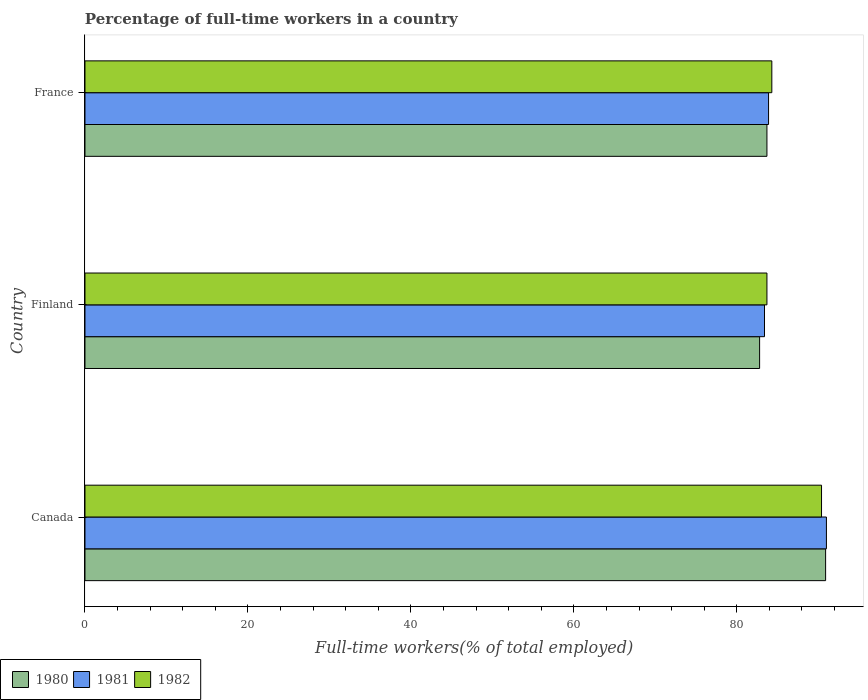How many different coloured bars are there?
Offer a terse response. 3. Are the number of bars per tick equal to the number of legend labels?
Offer a very short reply. Yes. Are the number of bars on each tick of the Y-axis equal?
Give a very brief answer. Yes. How many bars are there on the 2nd tick from the top?
Your answer should be compact. 3. How many bars are there on the 3rd tick from the bottom?
Your response must be concise. 3. What is the label of the 3rd group of bars from the top?
Give a very brief answer. Canada. What is the percentage of full-time workers in 1981 in France?
Your answer should be compact. 83.9. Across all countries, what is the maximum percentage of full-time workers in 1982?
Offer a very short reply. 90.4. Across all countries, what is the minimum percentage of full-time workers in 1980?
Keep it short and to the point. 82.8. In which country was the percentage of full-time workers in 1980 minimum?
Ensure brevity in your answer.  Finland. What is the total percentage of full-time workers in 1980 in the graph?
Provide a succinct answer. 257.4. What is the difference between the percentage of full-time workers in 1980 in Finland and that in France?
Offer a terse response. -0.9. What is the difference between the percentage of full-time workers in 1981 in France and the percentage of full-time workers in 1980 in Finland?
Provide a succinct answer. 1.1. What is the average percentage of full-time workers in 1982 per country?
Give a very brief answer. 86.13. What is the difference between the percentage of full-time workers in 1981 and percentage of full-time workers in 1980 in Finland?
Ensure brevity in your answer.  0.6. What is the ratio of the percentage of full-time workers in 1981 in Canada to that in Finland?
Your answer should be very brief. 1.09. Is the percentage of full-time workers in 1981 in Canada less than that in France?
Ensure brevity in your answer.  No. What is the difference between the highest and the second highest percentage of full-time workers in 1982?
Provide a short and direct response. 6.1. What is the difference between the highest and the lowest percentage of full-time workers in 1982?
Offer a terse response. 6.7. In how many countries, is the percentage of full-time workers in 1982 greater than the average percentage of full-time workers in 1982 taken over all countries?
Ensure brevity in your answer.  1. Is the sum of the percentage of full-time workers in 1980 in Canada and Finland greater than the maximum percentage of full-time workers in 1982 across all countries?
Give a very brief answer. Yes. What does the 2nd bar from the top in Canada represents?
Your answer should be compact. 1981. What does the 2nd bar from the bottom in Finland represents?
Make the answer very short. 1981. How many countries are there in the graph?
Provide a short and direct response. 3. What is the difference between two consecutive major ticks on the X-axis?
Make the answer very short. 20. Are the values on the major ticks of X-axis written in scientific E-notation?
Offer a terse response. No. Does the graph contain any zero values?
Provide a short and direct response. No. How many legend labels are there?
Your answer should be compact. 3. How are the legend labels stacked?
Provide a succinct answer. Horizontal. What is the title of the graph?
Keep it short and to the point. Percentage of full-time workers in a country. What is the label or title of the X-axis?
Provide a succinct answer. Full-time workers(% of total employed). What is the label or title of the Y-axis?
Give a very brief answer. Country. What is the Full-time workers(% of total employed) in 1980 in Canada?
Keep it short and to the point. 90.9. What is the Full-time workers(% of total employed) of 1981 in Canada?
Your answer should be very brief. 91. What is the Full-time workers(% of total employed) of 1982 in Canada?
Keep it short and to the point. 90.4. What is the Full-time workers(% of total employed) of 1980 in Finland?
Offer a terse response. 82.8. What is the Full-time workers(% of total employed) of 1981 in Finland?
Offer a terse response. 83.4. What is the Full-time workers(% of total employed) of 1982 in Finland?
Make the answer very short. 83.7. What is the Full-time workers(% of total employed) in 1980 in France?
Provide a succinct answer. 83.7. What is the Full-time workers(% of total employed) in 1981 in France?
Your answer should be compact. 83.9. What is the Full-time workers(% of total employed) of 1982 in France?
Your response must be concise. 84.3. Across all countries, what is the maximum Full-time workers(% of total employed) in 1980?
Your answer should be compact. 90.9. Across all countries, what is the maximum Full-time workers(% of total employed) of 1981?
Your answer should be compact. 91. Across all countries, what is the maximum Full-time workers(% of total employed) in 1982?
Offer a terse response. 90.4. Across all countries, what is the minimum Full-time workers(% of total employed) of 1980?
Your answer should be compact. 82.8. Across all countries, what is the minimum Full-time workers(% of total employed) of 1981?
Provide a succinct answer. 83.4. Across all countries, what is the minimum Full-time workers(% of total employed) of 1982?
Provide a succinct answer. 83.7. What is the total Full-time workers(% of total employed) in 1980 in the graph?
Your answer should be compact. 257.4. What is the total Full-time workers(% of total employed) in 1981 in the graph?
Make the answer very short. 258.3. What is the total Full-time workers(% of total employed) in 1982 in the graph?
Offer a terse response. 258.4. What is the difference between the Full-time workers(% of total employed) of 1980 in Canada and that in France?
Offer a terse response. 7.2. What is the difference between the Full-time workers(% of total employed) in 1981 in Finland and that in France?
Offer a very short reply. -0.5. What is the difference between the Full-time workers(% of total employed) in 1980 in Canada and the Full-time workers(% of total employed) in 1982 in Finland?
Your response must be concise. 7.2. What is the difference between the Full-time workers(% of total employed) of 1980 in Canada and the Full-time workers(% of total employed) of 1981 in France?
Offer a very short reply. 7. What is the difference between the Full-time workers(% of total employed) of 1980 in Canada and the Full-time workers(% of total employed) of 1982 in France?
Offer a very short reply. 6.6. What is the difference between the Full-time workers(% of total employed) of 1980 in Finland and the Full-time workers(% of total employed) of 1981 in France?
Make the answer very short. -1.1. What is the difference between the Full-time workers(% of total employed) of 1981 in Finland and the Full-time workers(% of total employed) of 1982 in France?
Your response must be concise. -0.9. What is the average Full-time workers(% of total employed) of 1980 per country?
Offer a terse response. 85.8. What is the average Full-time workers(% of total employed) in 1981 per country?
Ensure brevity in your answer.  86.1. What is the average Full-time workers(% of total employed) of 1982 per country?
Your answer should be compact. 86.13. What is the difference between the Full-time workers(% of total employed) in 1980 and Full-time workers(% of total employed) in 1981 in Canada?
Provide a short and direct response. -0.1. What is the difference between the Full-time workers(% of total employed) of 1980 and Full-time workers(% of total employed) of 1982 in Finland?
Offer a very short reply. -0.9. What is the difference between the Full-time workers(% of total employed) of 1981 and Full-time workers(% of total employed) of 1982 in Finland?
Make the answer very short. -0.3. What is the difference between the Full-time workers(% of total employed) of 1980 and Full-time workers(% of total employed) of 1982 in France?
Provide a succinct answer. -0.6. What is the difference between the Full-time workers(% of total employed) in 1981 and Full-time workers(% of total employed) in 1982 in France?
Offer a terse response. -0.4. What is the ratio of the Full-time workers(% of total employed) of 1980 in Canada to that in Finland?
Ensure brevity in your answer.  1.1. What is the ratio of the Full-time workers(% of total employed) of 1981 in Canada to that in Finland?
Your response must be concise. 1.09. What is the ratio of the Full-time workers(% of total employed) in 1982 in Canada to that in Finland?
Your answer should be compact. 1.08. What is the ratio of the Full-time workers(% of total employed) of 1980 in Canada to that in France?
Offer a terse response. 1.09. What is the ratio of the Full-time workers(% of total employed) in 1981 in Canada to that in France?
Offer a very short reply. 1.08. What is the ratio of the Full-time workers(% of total employed) in 1982 in Canada to that in France?
Your answer should be compact. 1.07. What is the difference between the highest and the second highest Full-time workers(% of total employed) of 1981?
Make the answer very short. 7.1. What is the difference between the highest and the lowest Full-time workers(% of total employed) of 1981?
Provide a short and direct response. 7.6. 